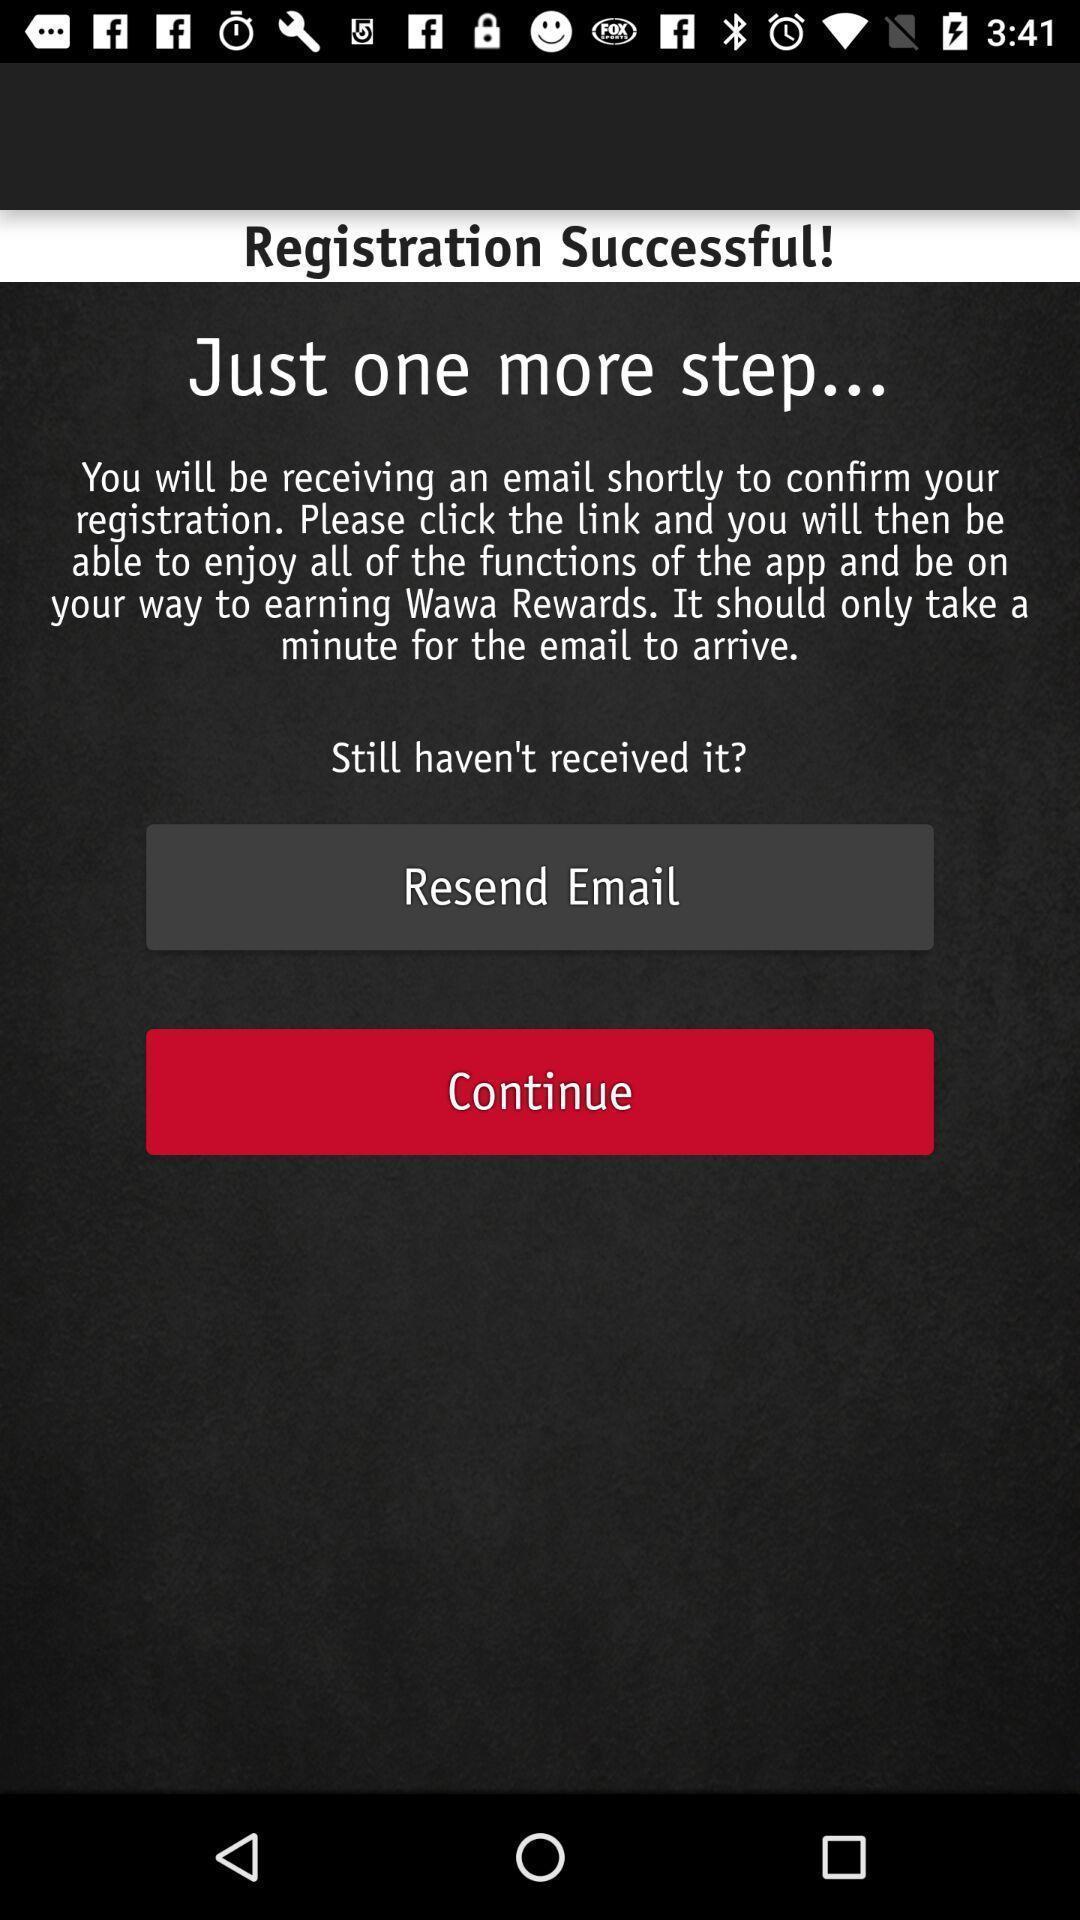Describe the visual elements of this screenshot. Screen displaying the registration successful notification. 